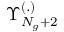Convert formula to latex. <formula><loc_0><loc_0><loc_500><loc_500>\Upsilon _ { N _ { g } + 2 } ^ { ( . ) }</formula> 